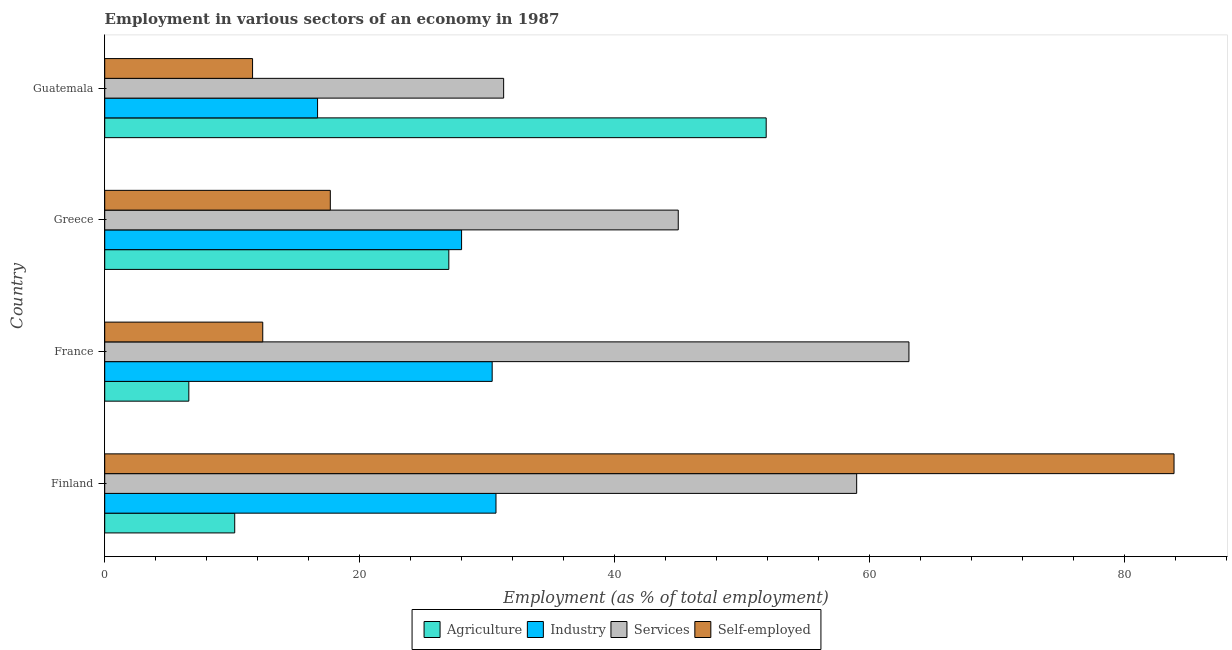Are the number of bars per tick equal to the number of legend labels?
Your response must be concise. Yes. What is the label of the 1st group of bars from the top?
Your answer should be very brief. Guatemala. In how many cases, is the number of bars for a given country not equal to the number of legend labels?
Keep it short and to the point. 0. What is the percentage of self employed workers in Finland?
Offer a very short reply. 83.9. Across all countries, what is the maximum percentage of workers in industry?
Make the answer very short. 30.7. Across all countries, what is the minimum percentage of workers in industry?
Offer a terse response. 16.7. In which country was the percentage of workers in agriculture maximum?
Give a very brief answer. Guatemala. In which country was the percentage of self employed workers minimum?
Provide a short and direct response. Guatemala. What is the total percentage of self employed workers in the graph?
Offer a terse response. 125.6. What is the difference between the percentage of workers in services in Finland and that in France?
Make the answer very short. -4.1. What is the difference between the percentage of self employed workers in Greece and the percentage of workers in industry in France?
Provide a succinct answer. -12.7. What is the average percentage of workers in agriculture per country?
Your answer should be very brief. 23.93. In how many countries, is the percentage of workers in services greater than 20 %?
Your response must be concise. 4. What is the ratio of the percentage of workers in services in Finland to that in France?
Your answer should be compact. 0.94. Is the difference between the percentage of workers in industry in Finland and Greece greater than the difference between the percentage of workers in agriculture in Finland and Greece?
Give a very brief answer. Yes. What is the difference between the highest and the second highest percentage of self employed workers?
Keep it short and to the point. 66.2. What is the difference between the highest and the lowest percentage of self employed workers?
Keep it short and to the point. 72.3. In how many countries, is the percentage of workers in services greater than the average percentage of workers in services taken over all countries?
Offer a very short reply. 2. Is the sum of the percentage of workers in agriculture in Greece and Guatemala greater than the maximum percentage of workers in industry across all countries?
Ensure brevity in your answer.  Yes. Is it the case that in every country, the sum of the percentage of workers in agriculture and percentage of workers in services is greater than the sum of percentage of workers in industry and percentage of self employed workers?
Provide a succinct answer. Yes. What does the 4th bar from the top in Guatemala represents?
Keep it short and to the point. Agriculture. What does the 3rd bar from the bottom in Guatemala represents?
Your response must be concise. Services. Is it the case that in every country, the sum of the percentage of workers in agriculture and percentage of workers in industry is greater than the percentage of workers in services?
Offer a terse response. No. How many countries are there in the graph?
Ensure brevity in your answer.  4. What is the difference between two consecutive major ticks on the X-axis?
Keep it short and to the point. 20. Does the graph contain any zero values?
Keep it short and to the point. No. Does the graph contain grids?
Ensure brevity in your answer.  No. Where does the legend appear in the graph?
Your response must be concise. Bottom center. How many legend labels are there?
Make the answer very short. 4. What is the title of the graph?
Ensure brevity in your answer.  Employment in various sectors of an economy in 1987. What is the label or title of the X-axis?
Give a very brief answer. Employment (as % of total employment). What is the Employment (as % of total employment) of Agriculture in Finland?
Ensure brevity in your answer.  10.2. What is the Employment (as % of total employment) in Industry in Finland?
Provide a succinct answer. 30.7. What is the Employment (as % of total employment) of Services in Finland?
Offer a very short reply. 59. What is the Employment (as % of total employment) of Self-employed in Finland?
Your response must be concise. 83.9. What is the Employment (as % of total employment) of Agriculture in France?
Make the answer very short. 6.6. What is the Employment (as % of total employment) of Industry in France?
Make the answer very short. 30.4. What is the Employment (as % of total employment) in Services in France?
Your response must be concise. 63.1. What is the Employment (as % of total employment) of Self-employed in France?
Your response must be concise. 12.4. What is the Employment (as % of total employment) in Agriculture in Greece?
Your answer should be very brief. 27. What is the Employment (as % of total employment) of Self-employed in Greece?
Your answer should be very brief. 17.7. What is the Employment (as % of total employment) of Agriculture in Guatemala?
Provide a succinct answer. 51.9. What is the Employment (as % of total employment) in Industry in Guatemala?
Offer a terse response. 16.7. What is the Employment (as % of total employment) in Services in Guatemala?
Your answer should be compact. 31.3. What is the Employment (as % of total employment) of Self-employed in Guatemala?
Your answer should be compact. 11.6. Across all countries, what is the maximum Employment (as % of total employment) of Agriculture?
Make the answer very short. 51.9. Across all countries, what is the maximum Employment (as % of total employment) in Industry?
Ensure brevity in your answer.  30.7. Across all countries, what is the maximum Employment (as % of total employment) of Services?
Your answer should be very brief. 63.1. Across all countries, what is the maximum Employment (as % of total employment) of Self-employed?
Keep it short and to the point. 83.9. Across all countries, what is the minimum Employment (as % of total employment) in Agriculture?
Offer a terse response. 6.6. Across all countries, what is the minimum Employment (as % of total employment) of Industry?
Keep it short and to the point. 16.7. Across all countries, what is the minimum Employment (as % of total employment) in Services?
Give a very brief answer. 31.3. Across all countries, what is the minimum Employment (as % of total employment) of Self-employed?
Offer a terse response. 11.6. What is the total Employment (as % of total employment) in Agriculture in the graph?
Provide a short and direct response. 95.7. What is the total Employment (as % of total employment) in Industry in the graph?
Provide a short and direct response. 105.8. What is the total Employment (as % of total employment) in Services in the graph?
Make the answer very short. 198.4. What is the total Employment (as % of total employment) in Self-employed in the graph?
Make the answer very short. 125.6. What is the difference between the Employment (as % of total employment) of Agriculture in Finland and that in France?
Your answer should be compact. 3.6. What is the difference between the Employment (as % of total employment) of Self-employed in Finland and that in France?
Your answer should be compact. 71.5. What is the difference between the Employment (as % of total employment) in Agriculture in Finland and that in Greece?
Offer a terse response. -16.8. What is the difference between the Employment (as % of total employment) of Services in Finland and that in Greece?
Give a very brief answer. 14. What is the difference between the Employment (as % of total employment) of Self-employed in Finland and that in Greece?
Offer a very short reply. 66.2. What is the difference between the Employment (as % of total employment) of Agriculture in Finland and that in Guatemala?
Make the answer very short. -41.7. What is the difference between the Employment (as % of total employment) of Industry in Finland and that in Guatemala?
Your answer should be compact. 14. What is the difference between the Employment (as % of total employment) of Services in Finland and that in Guatemala?
Offer a very short reply. 27.7. What is the difference between the Employment (as % of total employment) in Self-employed in Finland and that in Guatemala?
Keep it short and to the point. 72.3. What is the difference between the Employment (as % of total employment) in Agriculture in France and that in Greece?
Make the answer very short. -20.4. What is the difference between the Employment (as % of total employment) in Industry in France and that in Greece?
Your answer should be very brief. 2.4. What is the difference between the Employment (as % of total employment) in Agriculture in France and that in Guatemala?
Your answer should be compact. -45.3. What is the difference between the Employment (as % of total employment) in Services in France and that in Guatemala?
Your answer should be compact. 31.8. What is the difference between the Employment (as % of total employment) of Agriculture in Greece and that in Guatemala?
Ensure brevity in your answer.  -24.9. What is the difference between the Employment (as % of total employment) in Industry in Greece and that in Guatemala?
Give a very brief answer. 11.3. What is the difference between the Employment (as % of total employment) of Self-employed in Greece and that in Guatemala?
Your answer should be very brief. 6.1. What is the difference between the Employment (as % of total employment) of Agriculture in Finland and the Employment (as % of total employment) of Industry in France?
Your response must be concise. -20.2. What is the difference between the Employment (as % of total employment) in Agriculture in Finland and the Employment (as % of total employment) in Services in France?
Offer a very short reply. -52.9. What is the difference between the Employment (as % of total employment) in Agriculture in Finland and the Employment (as % of total employment) in Self-employed in France?
Offer a very short reply. -2.2. What is the difference between the Employment (as % of total employment) of Industry in Finland and the Employment (as % of total employment) of Services in France?
Keep it short and to the point. -32.4. What is the difference between the Employment (as % of total employment) of Services in Finland and the Employment (as % of total employment) of Self-employed in France?
Your response must be concise. 46.6. What is the difference between the Employment (as % of total employment) in Agriculture in Finland and the Employment (as % of total employment) in Industry in Greece?
Your answer should be very brief. -17.8. What is the difference between the Employment (as % of total employment) of Agriculture in Finland and the Employment (as % of total employment) of Services in Greece?
Offer a terse response. -34.8. What is the difference between the Employment (as % of total employment) of Industry in Finland and the Employment (as % of total employment) of Services in Greece?
Provide a short and direct response. -14.3. What is the difference between the Employment (as % of total employment) of Industry in Finland and the Employment (as % of total employment) of Self-employed in Greece?
Give a very brief answer. 13. What is the difference between the Employment (as % of total employment) in Services in Finland and the Employment (as % of total employment) in Self-employed in Greece?
Provide a short and direct response. 41.3. What is the difference between the Employment (as % of total employment) in Agriculture in Finland and the Employment (as % of total employment) in Industry in Guatemala?
Your answer should be compact. -6.5. What is the difference between the Employment (as % of total employment) of Agriculture in Finland and the Employment (as % of total employment) of Services in Guatemala?
Offer a very short reply. -21.1. What is the difference between the Employment (as % of total employment) in Agriculture in Finland and the Employment (as % of total employment) in Self-employed in Guatemala?
Give a very brief answer. -1.4. What is the difference between the Employment (as % of total employment) in Industry in Finland and the Employment (as % of total employment) in Services in Guatemala?
Your answer should be compact. -0.6. What is the difference between the Employment (as % of total employment) of Services in Finland and the Employment (as % of total employment) of Self-employed in Guatemala?
Offer a terse response. 47.4. What is the difference between the Employment (as % of total employment) in Agriculture in France and the Employment (as % of total employment) in Industry in Greece?
Your answer should be very brief. -21.4. What is the difference between the Employment (as % of total employment) of Agriculture in France and the Employment (as % of total employment) of Services in Greece?
Your answer should be compact. -38.4. What is the difference between the Employment (as % of total employment) in Agriculture in France and the Employment (as % of total employment) in Self-employed in Greece?
Your response must be concise. -11.1. What is the difference between the Employment (as % of total employment) in Industry in France and the Employment (as % of total employment) in Services in Greece?
Offer a very short reply. -14.6. What is the difference between the Employment (as % of total employment) of Services in France and the Employment (as % of total employment) of Self-employed in Greece?
Keep it short and to the point. 45.4. What is the difference between the Employment (as % of total employment) in Agriculture in France and the Employment (as % of total employment) in Industry in Guatemala?
Make the answer very short. -10.1. What is the difference between the Employment (as % of total employment) of Agriculture in France and the Employment (as % of total employment) of Services in Guatemala?
Keep it short and to the point. -24.7. What is the difference between the Employment (as % of total employment) in Industry in France and the Employment (as % of total employment) in Services in Guatemala?
Your answer should be very brief. -0.9. What is the difference between the Employment (as % of total employment) of Industry in France and the Employment (as % of total employment) of Self-employed in Guatemala?
Your response must be concise. 18.8. What is the difference between the Employment (as % of total employment) in Services in France and the Employment (as % of total employment) in Self-employed in Guatemala?
Your response must be concise. 51.5. What is the difference between the Employment (as % of total employment) of Agriculture in Greece and the Employment (as % of total employment) of Services in Guatemala?
Give a very brief answer. -4.3. What is the difference between the Employment (as % of total employment) in Agriculture in Greece and the Employment (as % of total employment) in Self-employed in Guatemala?
Make the answer very short. 15.4. What is the difference between the Employment (as % of total employment) of Industry in Greece and the Employment (as % of total employment) of Services in Guatemala?
Offer a terse response. -3.3. What is the difference between the Employment (as % of total employment) of Services in Greece and the Employment (as % of total employment) of Self-employed in Guatemala?
Provide a succinct answer. 33.4. What is the average Employment (as % of total employment) in Agriculture per country?
Make the answer very short. 23.93. What is the average Employment (as % of total employment) of Industry per country?
Keep it short and to the point. 26.45. What is the average Employment (as % of total employment) of Services per country?
Offer a terse response. 49.6. What is the average Employment (as % of total employment) in Self-employed per country?
Ensure brevity in your answer.  31.4. What is the difference between the Employment (as % of total employment) of Agriculture and Employment (as % of total employment) of Industry in Finland?
Provide a short and direct response. -20.5. What is the difference between the Employment (as % of total employment) of Agriculture and Employment (as % of total employment) of Services in Finland?
Your answer should be very brief. -48.8. What is the difference between the Employment (as % of total employment) of Agriculture and Employment (as % of total employment) of Self-employed in Finland?
Ensure brevity in your answer.  -73.7. What is the difference between the Employment (as % of total employment) of Industry and Employment (as % of total employment) of Services in Finland?
Provide a short and direct response. -28.3. What is the difference between the Employment (as % of total employment) of Industry and Employment (as % of total employment) of Self-employed in Finland?
Provide a succinct answer. -53.2. What is the difference between the Employment (as % of total employment) in Services and Employment (as % of total employment) in Self-employed in Finland?
Your answer should be very brief. -24.9. What is the difference between the Employment (as % of total employment) of Agriculture and Employment (as % of total employment) of Industry in France?
Provide a succinct answer. -23.8. What is the difference between the Employment (as % of total employment) of Agriculture and Employment (as % of total employment) of Services in France?
Keep it short and to the point. -56.5. What is the difference between the Employment (as % of total employment) in Industry and Employment (as % of total employment) in Services in France?
Provide a short and direct response. -32.7. What is the difference between the Employment (as % of total employment) of Industry and Employment (as % of total employment) of Self-employed in France?
Keep it short and to the point. 18. What is the difference between the Employment (as % of total employment) of Services and Employment (as % of total employment) of Self-employed in France?
Make the answer very short. 50.7. What is the difference between the Employment (as % of total employment) in Agriculture and Employment (as % of total employment) in Industry in Greece?
Your response must be concise. -1. What is the difference between the Employment (as % of total employment) in Agriculture and Employment (as % of total employment) in Services in Greece?
Make the answer very short. -18. What is the difference between the Employment (as % of total employment) in Agriculture and Employment (as % of total employment) in Self-employed in Greece?
Keep it short and to the point. 9.3. What is the difference between the Employment (as % of total employment) in Industry and Employment (as % of total employment) in Services in Greece?
Give a very brief answer. -17. What is the difference between the Employment (as % of total employment) in Services and Employment (as % of total employment) in Self-employed in Greece?
Ensure brevity in your answer.  27.3. What is the difference between the Employment (as % of total employment) of Agriculture and Employment (as % of total employment) of Industry in Guatemala?
Ensure brevity in your answer.  35.2. What is the difference between the Employment (as % of total employment) of Agriculture and Employment (as % of total employment) of Services in Guatemala?
Offer a very short reply. 20.6. What is the difference between the Employment (as % of total employment) in Agriculture and Employment (as % of total employment) in Self-employed in Guatemala?
Make the answer very short. 40.3. What is the difference between the Employment (as % of total employment) in Industry and Employment (as % of total employment) in Services in Guatemala?
Provide a succinct answer. -14.6. What is the difference between the Employment (as % of total employment) of Services and Employment (as % of total employment) of Self-employed in Guatemala?
Offer a very short reply. 19.7. What is the ratio of the Employment (as % of total employment) in Agriculture in Finland to that in France?
Ensure brevity in your answer.  1.55. What is the ratio of the Employment (as % of total employment) in Industry in Finland to that in France?
Offer a very short reply. 1.01. What is the ratio of the Employment (as % of total employment) of Services in Finland to that in France?
Make the answer very short. 0.94. What is the ratio of the Employment (as % of total employment) in Self-employed in Finland to that in France?
Provide a short and direct response. 6.77. What is the ratio of the Employment (as % of total employment) of Agriculture in Finland to that in Greece?
Provide a succinct answer. 0.38. What is the ratio of the Employment (as % of total employment) of Industry in Finland to that in Greece?
Provide a short and direct response. 1.1. What is the ratio of the Employment (as % of total employment) of Services in Finland to that in Greece?
Provide a short and direct response. 1.31. What is the ratio of the Employment (as % of total employment) of Self-employed in Finland to that in Greece?
Give a very brief answer. 4.74. What is the ratio of the Employment (as % of total employment) in Agriculture in Finland to that in Guatemala?
Provide a short and direct response. 0.2. What is the ratio of the Employment (as % of total employment) in Industry in Finland to that in Guatemala?
Offer a very short reply. 1.84. What is the ratio of the Employment (as % of total employment) of Services in Finland to that in Guatemala?
Your answer should be very brief. 1.89. What is the ratio of the Employment (as % of total employment) of Self-employed in Finland to that in Guatemala?
Your answer should be very brief. 7.23. What is the ratio of the Employment (as % of total employment) of Agriculture in France to that in Greece?
Your response must be concise. 0.24. What is the ratio of the Employment (as % of total employment) of Industry in France to that in Greece?
Ensure brevity in your answer.  1.09. What is the ratio of the Employment (as % of total employment) in Services in France to that in Greece?
Ensure brevity in your answer.  1.4. What is the ratio of the Employment (as % of total employment) of Self-employed in France to that in Greece?
Offer a terse response. 0.7. What is the ratio of the Employment (as % of total employment) of Agriculture in France to that in Guatemala?
Your response must be concise. 0.13. What is the ratio of the Employment (as % of total employment) of Industry in France to that in Guatemala?
Keep it short and to the point. 1.82. What is the ratio of the Employment (as % of total employment) in Services in France to that in Guatemala?
Keep it short and to the point. 2.02. What is the ratio of the Employment (as % of total employment) of Self-employed in France to that in Guatemala?
Your answer should be very brief. 1.07. What is the ratio of the Employment (as % of total employment) of Agriculture in Greece to that in Guatemala?
Provide a succinct answer. 0.52. What is the ratio of the Employment (as % of total employment) of Industry in Greece to that in Guatemala?
Offer a very short reply. 1.68. What is the ratio of the Employment (as % of total employment) in Services in Greece to that in Guatemala?
Ensure brevity in your answer.  1.44. What is the ratio of the Employment (as % of total employment) of Self-employed in Greece to that in Guatemala?
Provide a short and direct response. 1.53. What is the difference between the highest and the second highest Employment (as % of total employment) of Agriculture?
Your answer should be very brief. 24.9. What is the difference between the highest and the second highest Employment (as % of total employment) in Industry?
Keep it short and to the point. 0.3. What is the difference between the highest and the second highest Employment (as % of total employment) of Self-employed?
Offer a very short reply. 66.2. What is the difference between the highest and the lowest Employment (as % of total employment) in Agriculture?
Make the answer very short. 45.3. What is the difference between the highest and the lowest Employment (as % of total employment) in Industry?
Make the answer very short. 14. What is the difference between the highest and the lowest Employment (as % of total employment) in Services?
Provide a short and direct response. 31.8. What is the difference between the highest and the lowest Employment (as % of total employment) in Self-employed?
Provide a succinct answer. 72.3. 